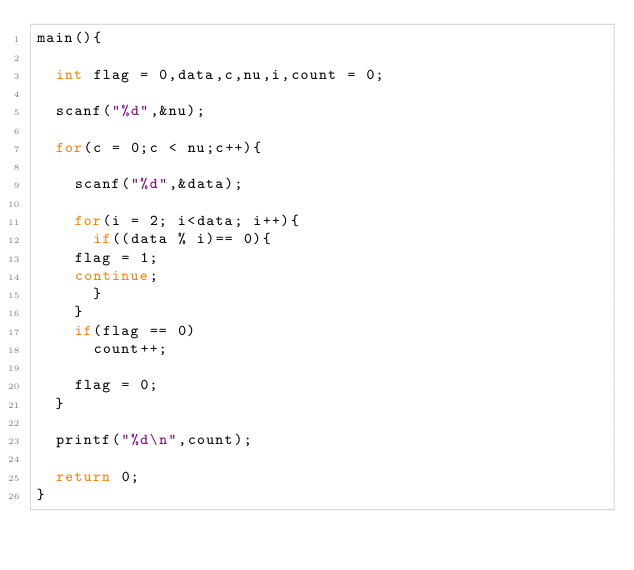<code> <loc_0><loc_0><loc_500><loc_500><_C_>main(){
  
  int flag = 0,data,c,nu,i,count = 0;
  
  scanf("%d",&nu);
  
  for(c = 0;c < nu;c++){
    
    scanf("%d",&data);
    
    for(i = 2; i<data; i++){
      if((data % i)== 0){
	flag = 1;      
	continue;
      }      
    }
    if(flag == 0)
      count++;
    
    flag = 0;
  }
  
  printf("%d\n",count);
  
  return 0;
}</code> 